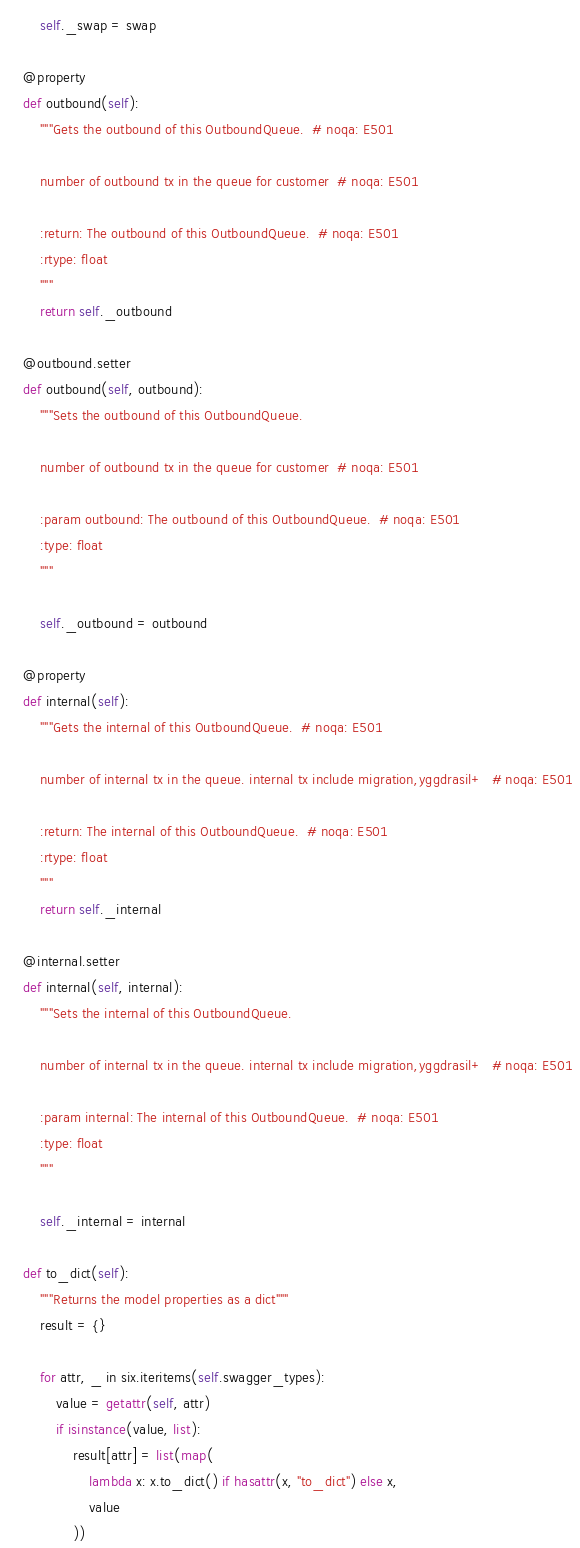Convert code to text. <code><loc_0><loc_0><loc_500><loc_500><_Python_>        self._swap = swap

    @property
    def outbound(self):
        """Gets the outbound of this OutboundQueue.  # noqa: E501

        number of outbound tx in the queue for customer  # noqa: E501

        :return: The outbound of this OutboundQueue.  # noqa: E501
        :rtype: float
        """
        return self._outbound

    @outbound.setter
    def outbound(self, outbound):
        """Sets the outbound of this OutboundQueue.

        number of outbound tx in the queue for customer  # noqa: E501

        :param outbound: The outbound of this OutboundQueue.  # noqa: E501
        :type: float
        """

        self._outbound = outbound

    @property
    def internal(self):
        """Gets the internal of this OutboundQueue.  # noqa: E501

        number of internal tx in the queue. internal tx include migration,yggdrasil+  # noqa: E501

        :return: The internal of this OutboundQueue.  # noqa: E501
        :rtype: float
        """
        return self._internal

    @internal.setter
    def internal(self, internal):
        """Sets the internal of this OutboundQueue.

        number of internal tx in the queue. internal tx include migration,yggdrasil+  # noqa: E501

        :param internal: The internal of this OutboundQueue.  # noqa: E501
        :type: float
        """

        self._internal = internal

    def to_dict(self):
        """Returns the model properties as a dict"""
        result = {}

        for attr, _ in six.iteritems(self.swagger_types):
            value = getattr(self, attr)
            if isinstance(value, list):
                result[attr] = list(map(
                    lambda x: x.to_dict() if hasattr(x, "to_dict") else x,
                    value
                ))</code> 